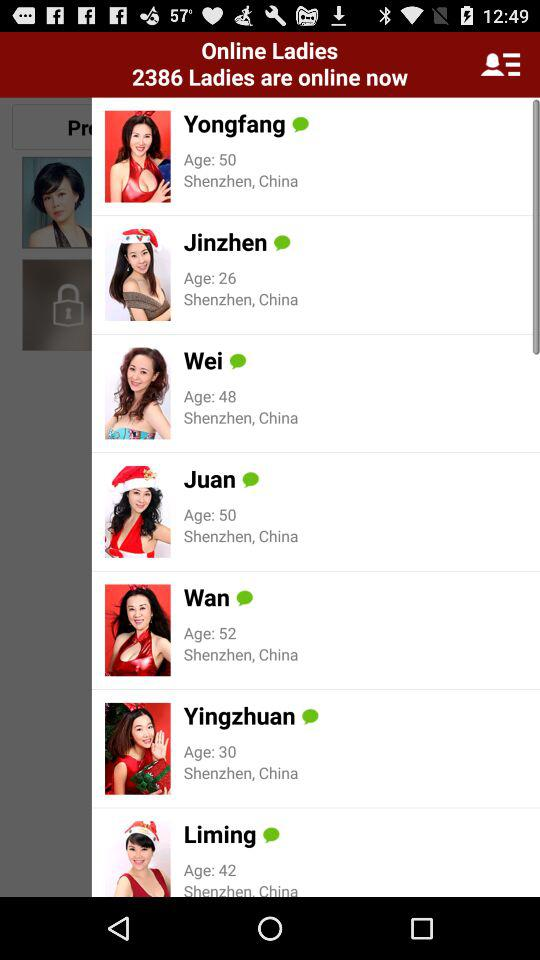How many ladies are on line? There are 2386 ladies online. 